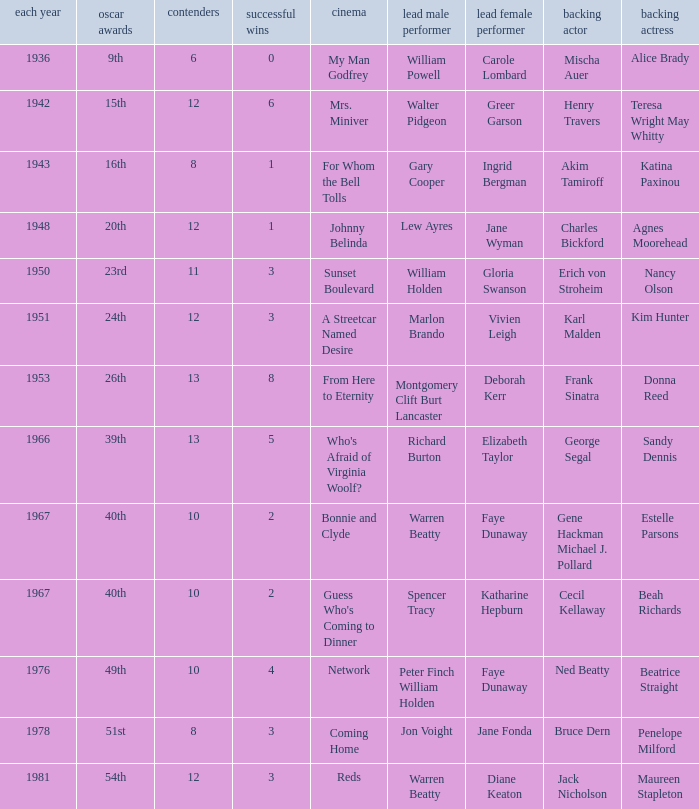Who was the leading actor in the film with a supporting actor named Cecil Kellaway? Spencer Tracy. 